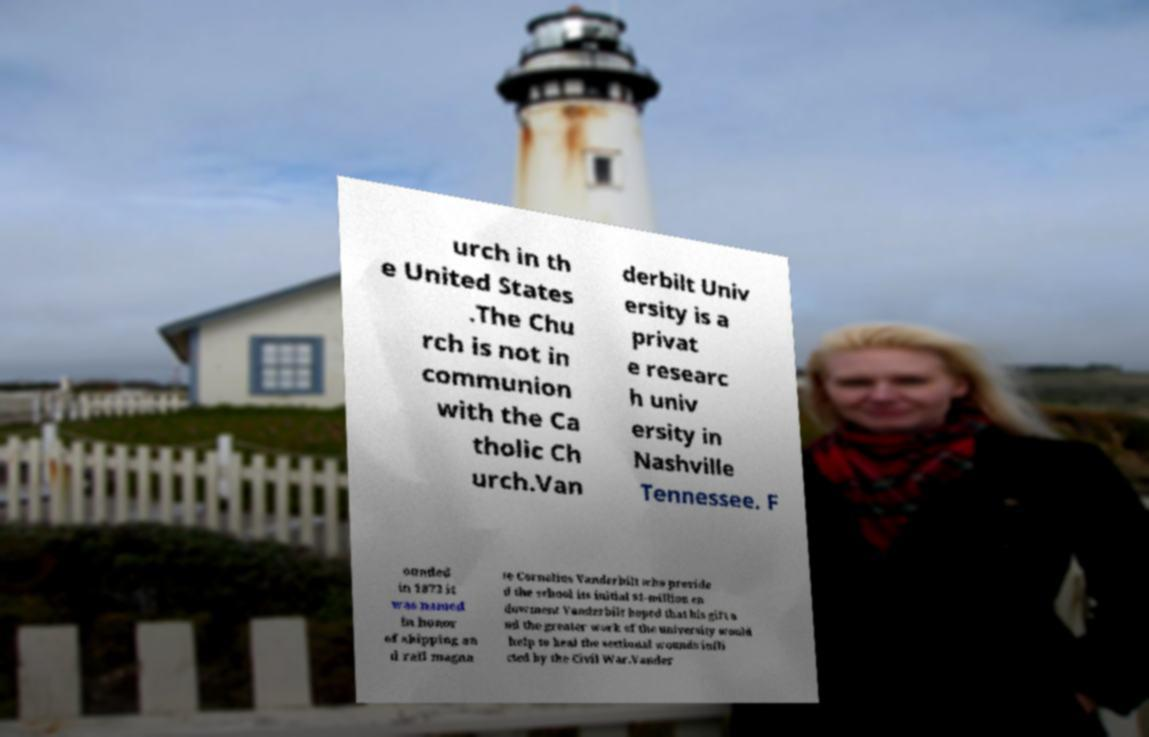Could you extract and type out the text from this image? urch in th e United States .The Chu rch is not in communion with the Ca tholic Ch urch.Van derbilt Univ ersity is a privat e researc h univ ersity in Nashville Tennessee. F ounded in 1873 it was named in honor of shipping an d rail magna te Cornelius Vanderbilt who provide d the school its initial $1-million en dowment Vanderbilt hoped that his gift a nd the greater work of the university would help to heal the sectional wounds infli cted by the Civil War.Vander 